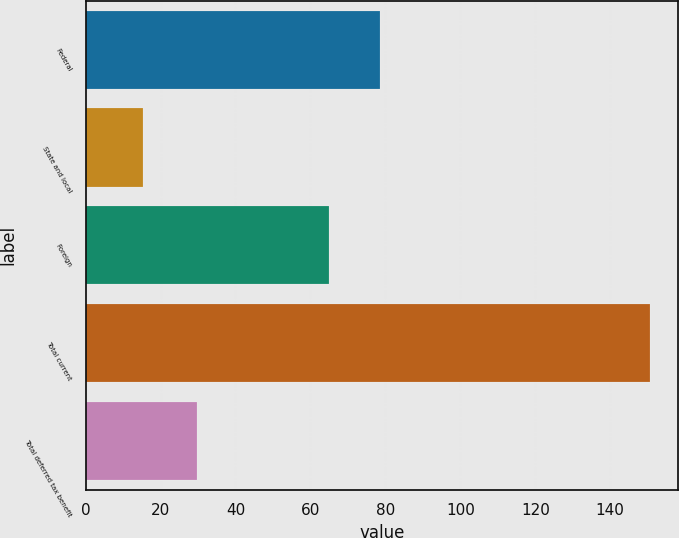Convert chart. <chart><loc_0><loc_0><loc_500><loc_500><bar_chart><fcel>Federal<fcel>State and local<fcel>Foreign<fcel>Total current<fcel>Total deferred tax benefit<nl><fcel>78.53<fcel>15.3<fcel>65<fcel>150.6<fcel>29.8<nl></chart> 